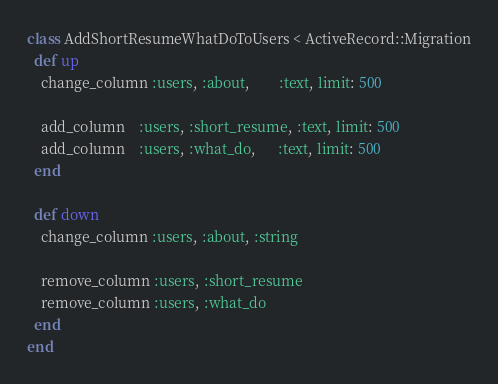Convert code to text. <code><loc_0><loc_0><loc_500><loc_500><_Ruby_>class AddShortResumeWhatDoToUsers < ActiveRecord::Migration
  def up
    change_column :users, :about,        :text, limit: 500
    
    add_column    :users, :short_resume, :text, limit: 500
    add_column    :users, :what_do,      :text, limit: 500
  end
  
  def down
    change_column :users, :about, :string
    
    remove_column :users, :short_resume
    remove_column :users, :what_do
  end
end
</code> 